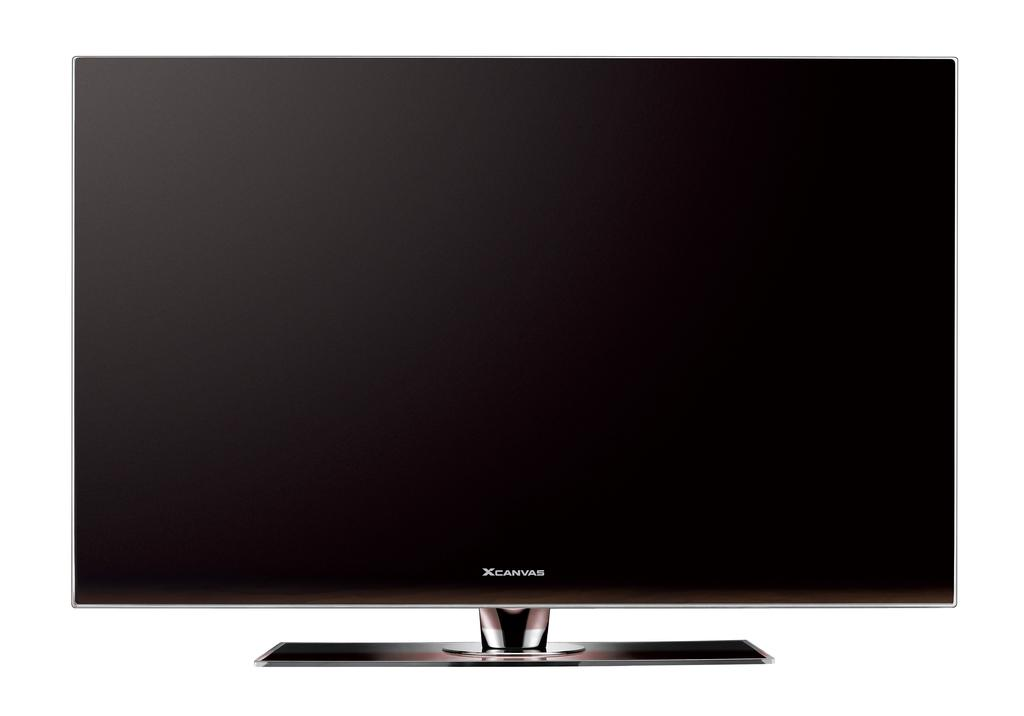What electronic device is present in the image? There is a TV in the image. What type of cap is the TV wearing in the image? There is no cap present in the image, as the TV is an electronic device and does not wear clothing or accessories. 